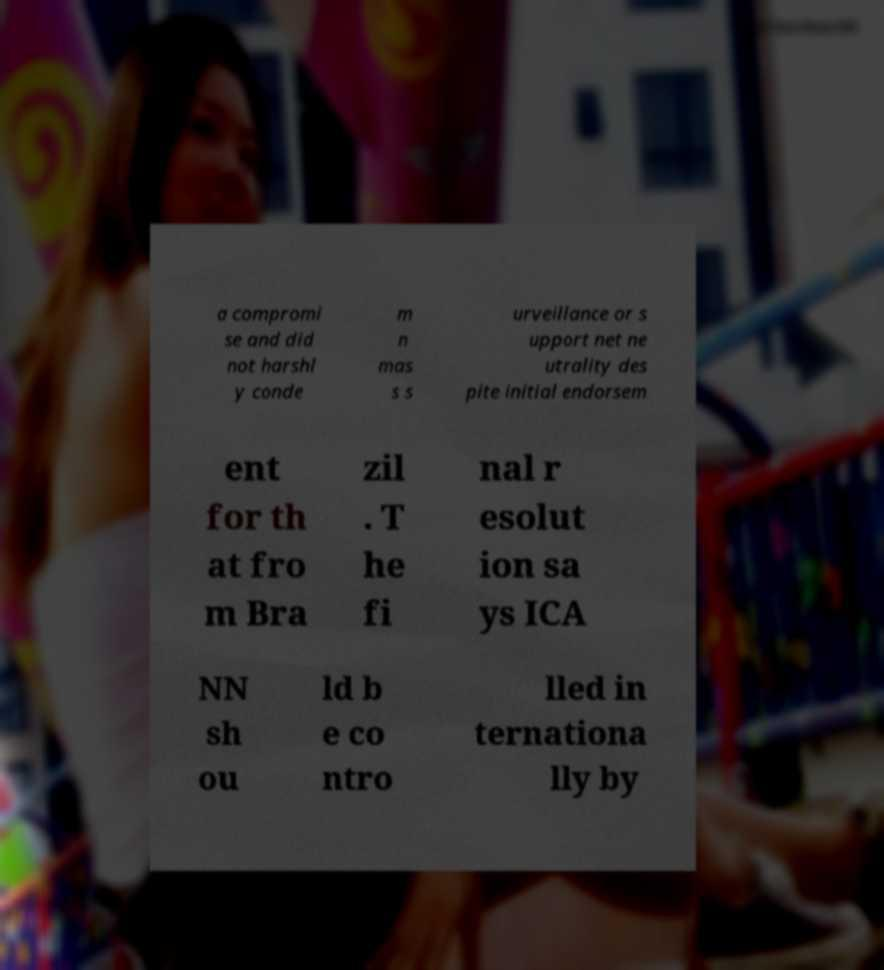For documentation purposes, I need the text within this image transcribed. Could you provide that? a compromi se and did not harshl y conde m n mas s s urveillance or s upport net ne utrality des pite initial endorsem ent for th at fro m Bra zil . T he fi nal r esolut ion sa ys ICA NN sh ou ld b e co ntro lled in ternationa lly by 